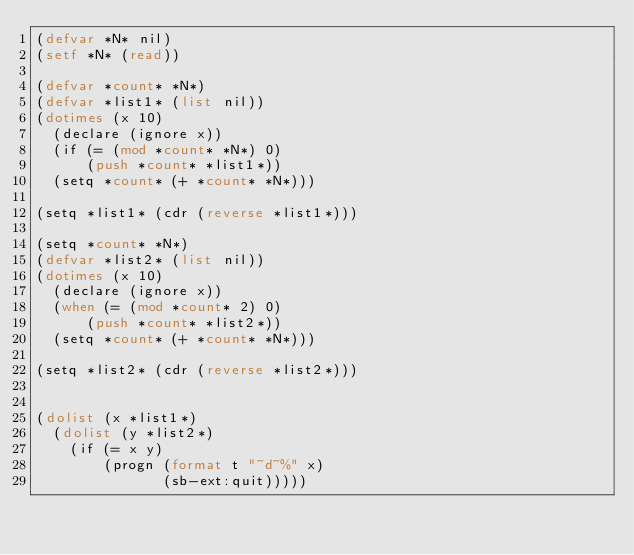<code> <loc_0><loc_0><loc_500><loc_500><_Lisp_>(defvar *N* nil)
(setf *N* (read))

(defvar *count* *N*)
(defvar *list1* (list nil))
(dotimes (x 10)
  (declare (ignore x))
  (if (= (mod *count* *N*) 0)
      (push *count* *list1*))
  (setq *count* (+ *count* *N*)))

(setq *list1* (cdr (reverse *list1*)))

(setq *count* *N*)
(defvar *list2* (list nil))
(dotimes (x 10)
  (declare (ignore x))
  (when (= (mod *count* 2) 0)
      (push *count* *list2*))
  (setq *count* (+ *count* *N*)))

(setq *list2* (cdr (reverse *list2*)))


(dolist (x *list1*)
  (dolist (y *list2*)
    (if (= x y)
        (progn (format t "~d~%" x)
               (sb-ext:quit)))))

</code> 